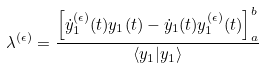Convert formula to latex. <formula><loc_0><loc_0><loc_500><loc_500>\lambda ^ { ( \epsilon ) } = \frac { \left [ \dot { y } ^ { ( \epsilon ) } _ { 1 } ( t ) y _ { 1 } ( t ) - \dot { y } _ { 1 } ( t ) y ^ { ( \epsilon ) } _ { 1 } ( t ) \right ] ^ { b } _ { a } } { \langle y _ { 1 } | y _ { 1 } \rangle }</formula> 